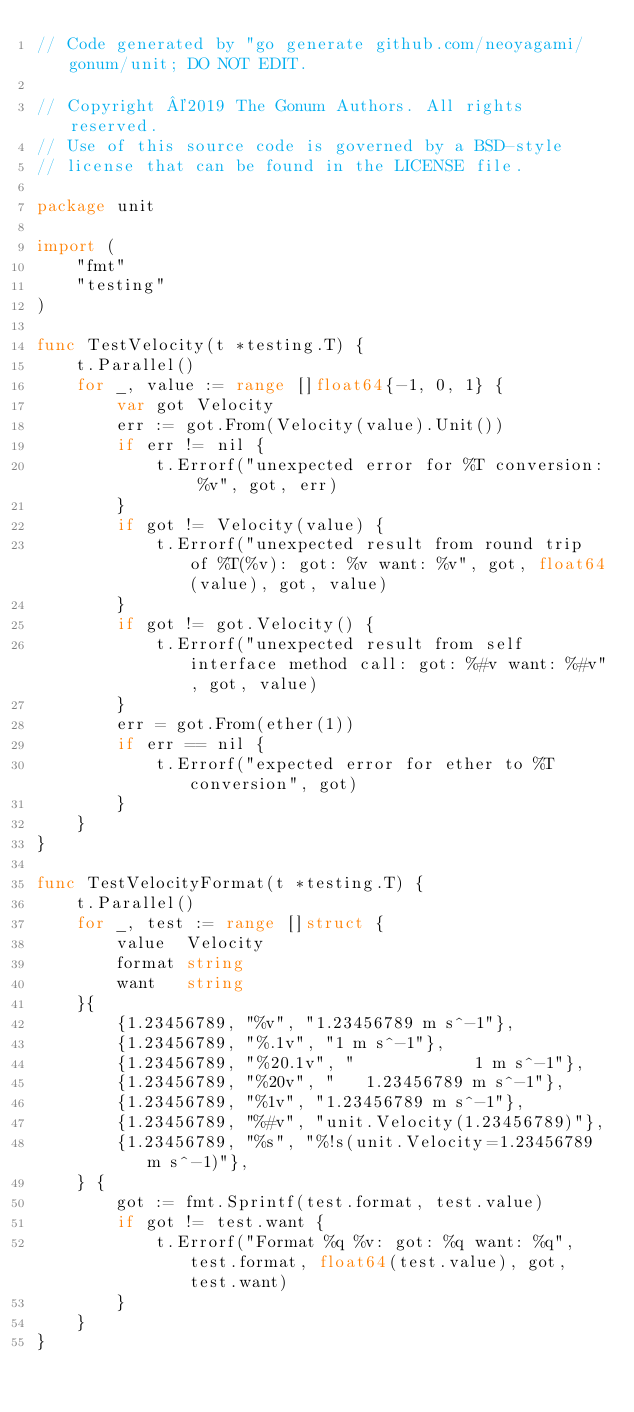Convert code to text. <code><loc_0><loc_0><loc_500><loc_500><_Go_>// Code generated by "go generate github.com/neoyagami/gonum/unit; DO NOT EDIT.

// Copyright ©2019 The Gonum Authors. All rights reserved.
// Use of this source code is governed by a BSD-style
// license that can be found in the LICENSE file.

package unit

import (
	"fmt"
	"testing"
)

func TestVelocity(t *testing.T) {
	t.Parallel()
	for _, value := range []float64{-1, 0, 1} {
		var got Velocity
		err := got.From(Velocity(value).Unit())
		if err != nil {
			t.Errorf("unexpected error for %T conversion: %v", got, err)
		}
		if got != Velocity(value) {
			t.Errorf("unexpected result from round trip of %T(%v): got: %v want: %v", got, float64(value), got, value)
		}
		if got != got.Velocity() {
			t.Errorf("unexpected result from self interface method call: got: %#v want: %#v", got, value)
		}
		err = got.From(ether(1))
		if err == nil {
			t.Errorf("expected error for ether to %T conversion", got)
		}
	}
}

func TestVelocityFormat(t *testing.T) {
	t.Parallel()
	for _, test := range []struct {
		value  Velocity
		format string
		want   string
	}{
		{1.23456789, "%v", "1.23456789 m s^-1"},
		{1.23456789, "%.1v", "1 m s^-1"},
		{1.23456789, "%20.1v", "            1 m s^-1"},
		{1.23456789, "%20v", "   1.23456789 m s^-1"},
		{1.23456789, "%1v", "1.23456789 m s^-1"},
		{1.23456789, "%#v", "unit.Velocity(1.23456789)"},
		{1.23456789, "%s", "%!s(unit.Velocity=1.23456789 m s^-1)"},
	} {
		got := fmt.Sprintf(test.format, test.value)
		if got != test.want {
			t.Errorf("Format %q %v: got: %q want: %q", test.format, float64(test.value), got, test.want)
		}
	}
}
</code> 